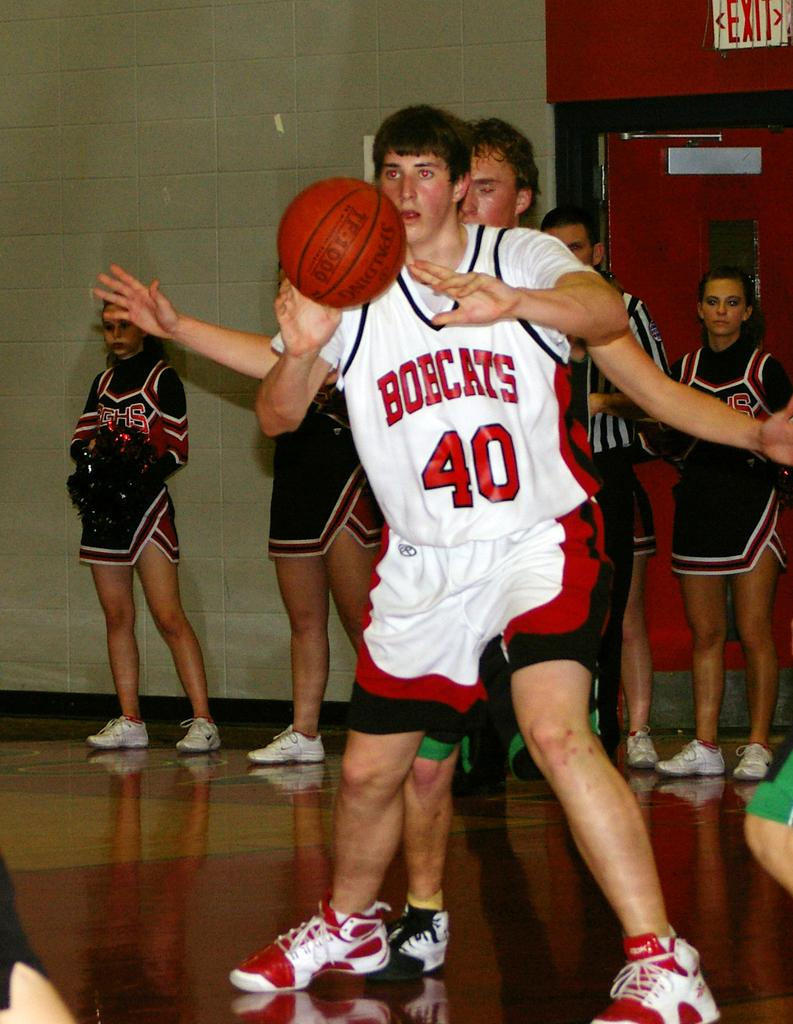<image>
Share a concise interpretation of the image provided. A basketball player has Bobcasts on his jersey. 